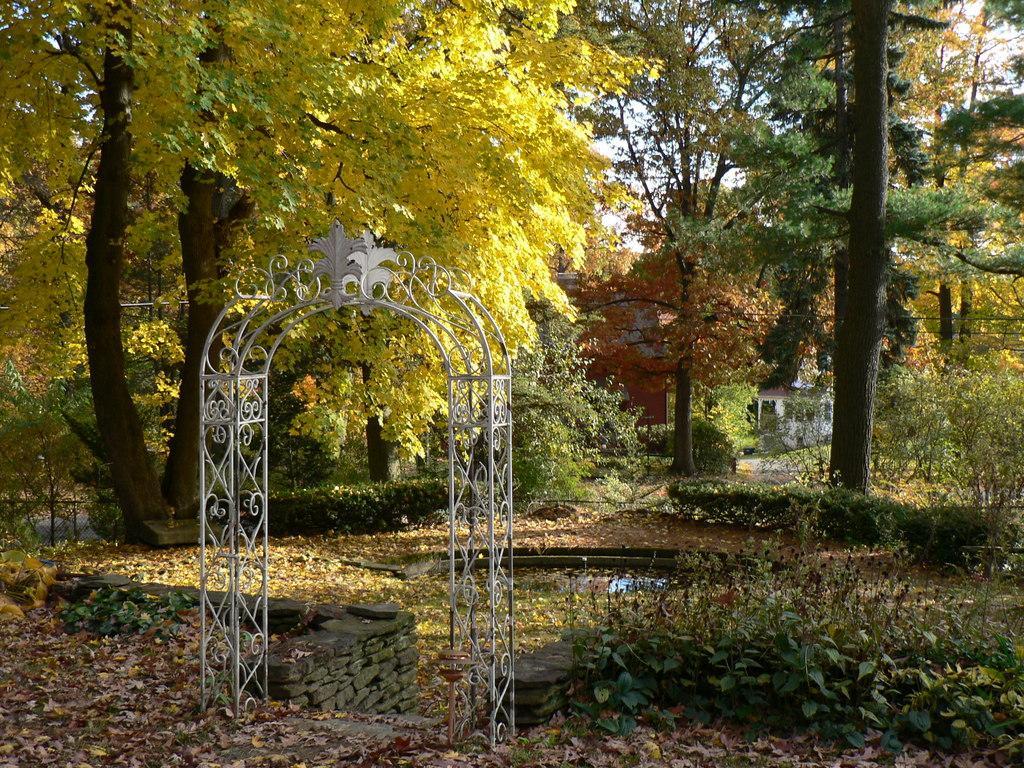Can you describe this image briefly? In this picture, we see an arch. At the bottom, we see the dry leaves and the shrubs. Behind the arch, we see a wall which is made up of stones. In the middle, we see the water in the pond. There are trees, shrubs and the buildings in the background. 